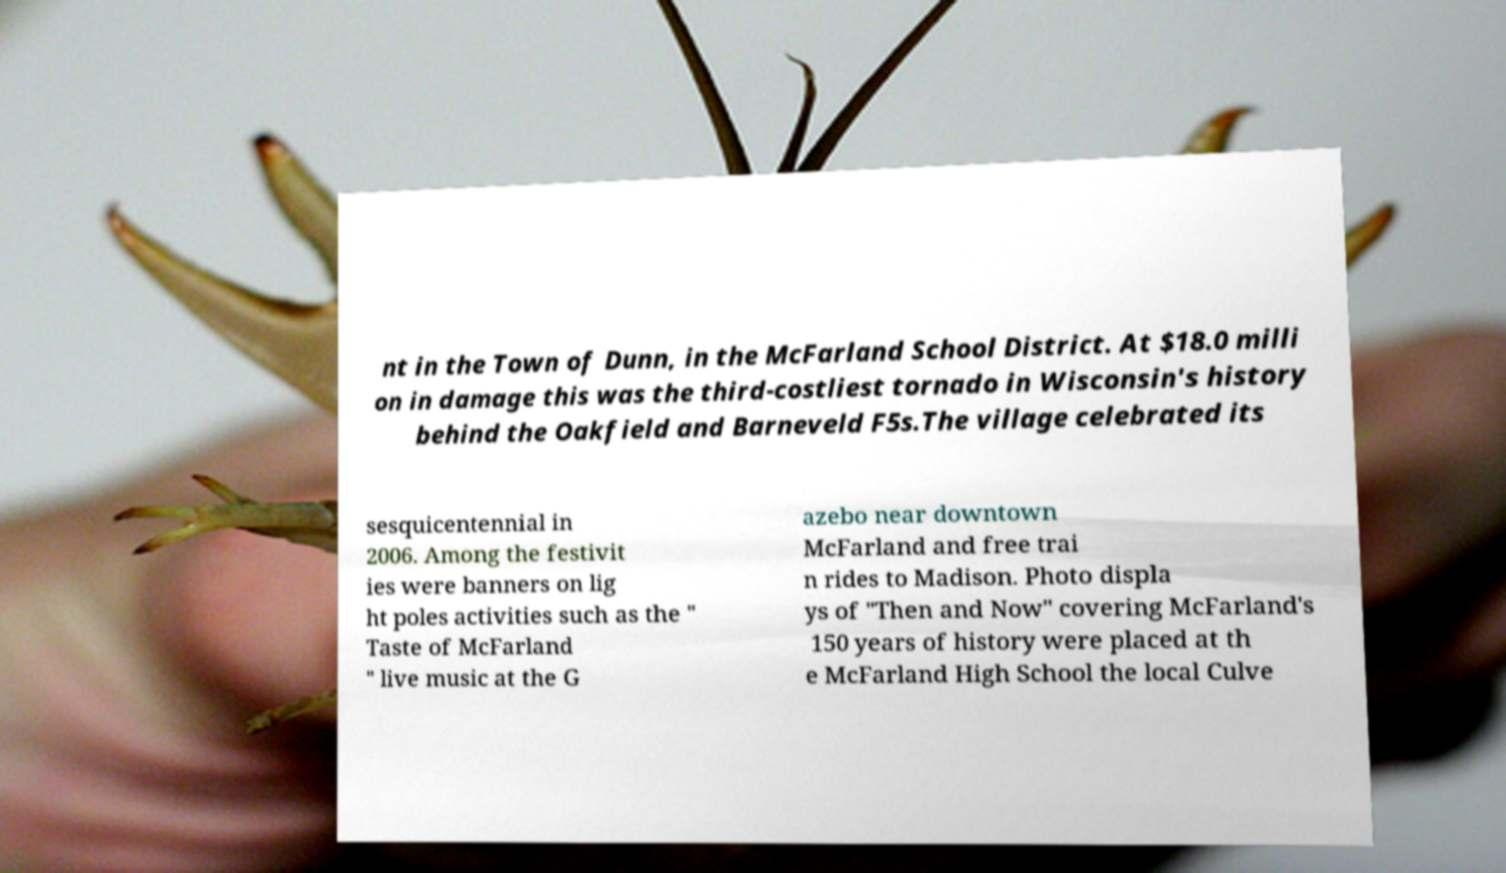Could you extract and type out the text from this image? nt in the Town of Dunn, in the McFarland School District. At $18.0 milli on in damage this was the third-costliest tornado in Wisconsin's history behind the Oakfield and Barneveld F5s.The village celebrated its sesquicentennial in 2006. Among the festivit ies were banners on lig ht poles activities such as the " Taste of McFarland " live music at the G azebo near downtown McFarland and free trai n rides to Madison. Photo displa ys of "Then and Now" covering McFarland's 150 years of history were placed at th e McFarland High School the local Culve 